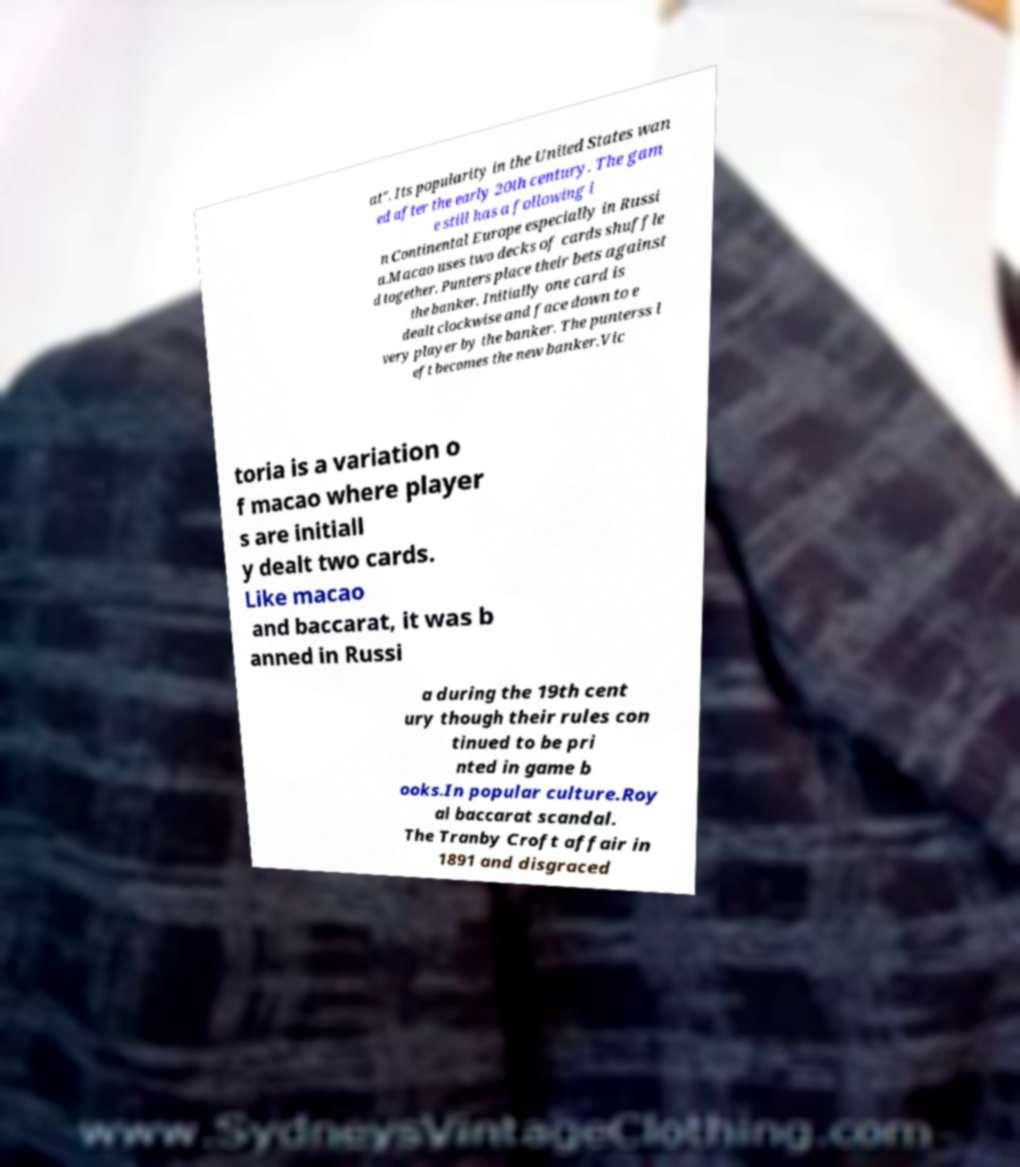Can you accurately transcribe the text from the provided image for me? at". Its popularity in the United States wan ed after the early 20th century. The gam e still has a following i n Continental Europe especially in Russi a.Macao uses two decks of cards shuffle d together. Punters place their bets against the banker. Initially one card is dealt clockwise and face down to e very player by the banker. The punterss l eft becomes the new banker.Vic toria is a variation o f macao where player s are initiall y dealt two cards. Like macao and baccarat, it was b anned in Russi a during the 19th cent ury though their rules con tinued to be pri nted in game b ooks.In popular culture.Roy al baccarat scandal. The Tranby Croft affair in 1891 and disgraced 